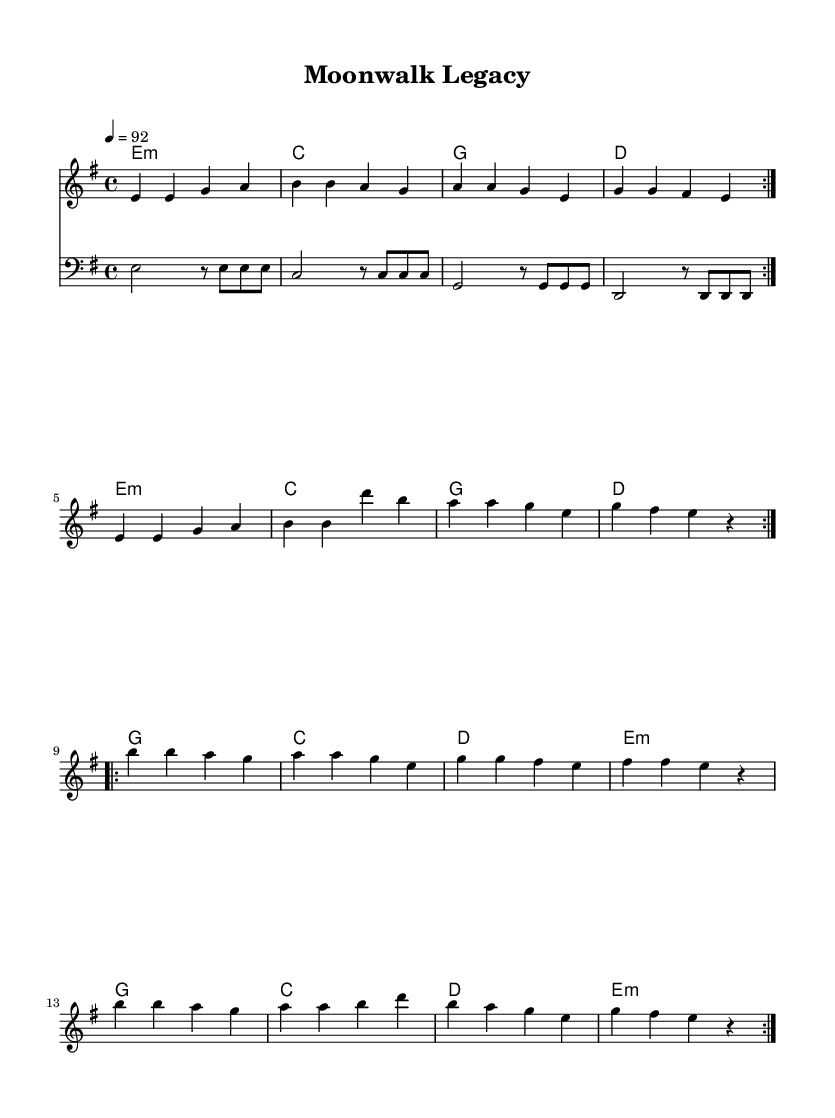What is the key signature of this music? The key signature is E minor, which has one sharp (F#). This can be determined by looking at the key signature indicated at the beginning of the score.
Answer: E minor What is the time signature of this music? The time signature is four-four, indicated by the "4/4" marking at the beginning of the score. This means there are four beats in each measure.
Answer: 4/4 What is the tempo marking of this music? The tempo marking is indicated as "4 = 92", which means that the quarter note gets 92 beats per minute. This can be found next to the tempo section at the beginning.
Answer: 92 How many measures are repeated in the first volta section? The first volta section includes 8 measures, which can be counted in the repeated section at the beginning of the melody.
Answer: 8 What chord follows E minor in the first section? The chord following E minor is C major, which is specified in the chord symbols under the melody line.
Answer: C What is the pattern of the bassline in the first section? The bassline has a repeated pattern of E, C, G, and D notes, indicated in the bass staff, showing a consistent 4-note cycle throughout the first section.
Answer: E, C, G, D What dance influence is suggested by the repeating measures? The repeating measures suggest a rhythmic, danceable beat typical in rap music, reflecting the influence of Michael Jackson's iconic dance styles. This can be inferred from the overall structure and rhythmic drive of the piece.
Answer: Danceable beat 